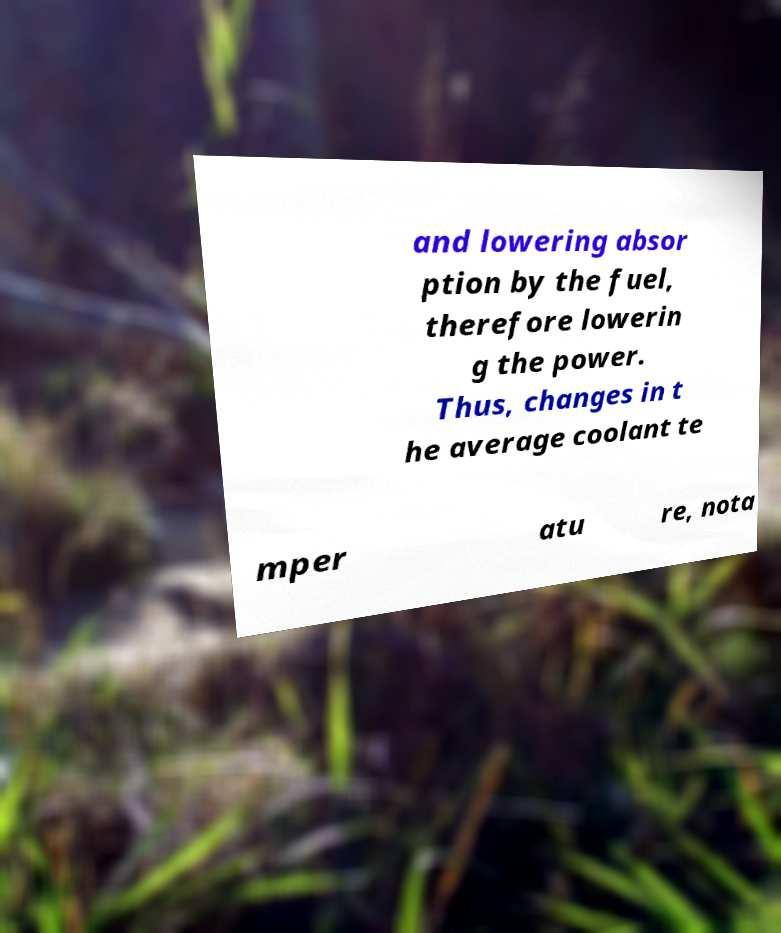Could you extract and type out the text from this image? and lowering absor ption by the fuel, therefore lowerin g the power. Thus, changes in t he average coolant te mper atu re, nota 